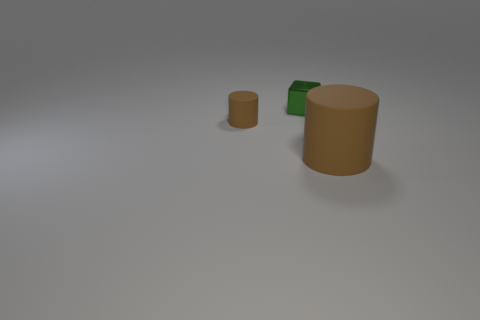There is another matte thing that is the same shape as the big matte object; what color is it?
Your answer should be compact. Brown. The metallic block is what size?
Make the answer very short. Small. What number of cubes are green metallic objects or tiny rubber things?
Your answer should be very brief. 1. There is another thing that is the same shape as the tiny brown rubber object; what is its size?
Keep it short and to the point. Large. What number of big brown matte cylinders are there?
Your answer should be very brief. 1. Do the big brown thing and the matte object on the left side of the metallic block have the same shape?
Offer a very short reply. Yes. There is a rubber cylinder behind the large brown thing; what size is it?
Provide a succinct answer. Small. What is the material of the green cube?
Provide a short and direct response. Metal. Does the matte thing left of the big matte object have the same shape as the green shiny thing?
Your answer should be compact. No. There is a matte thing that is the same color as the large matte cylinder; what size is it?
Make the answer very short. Small. 